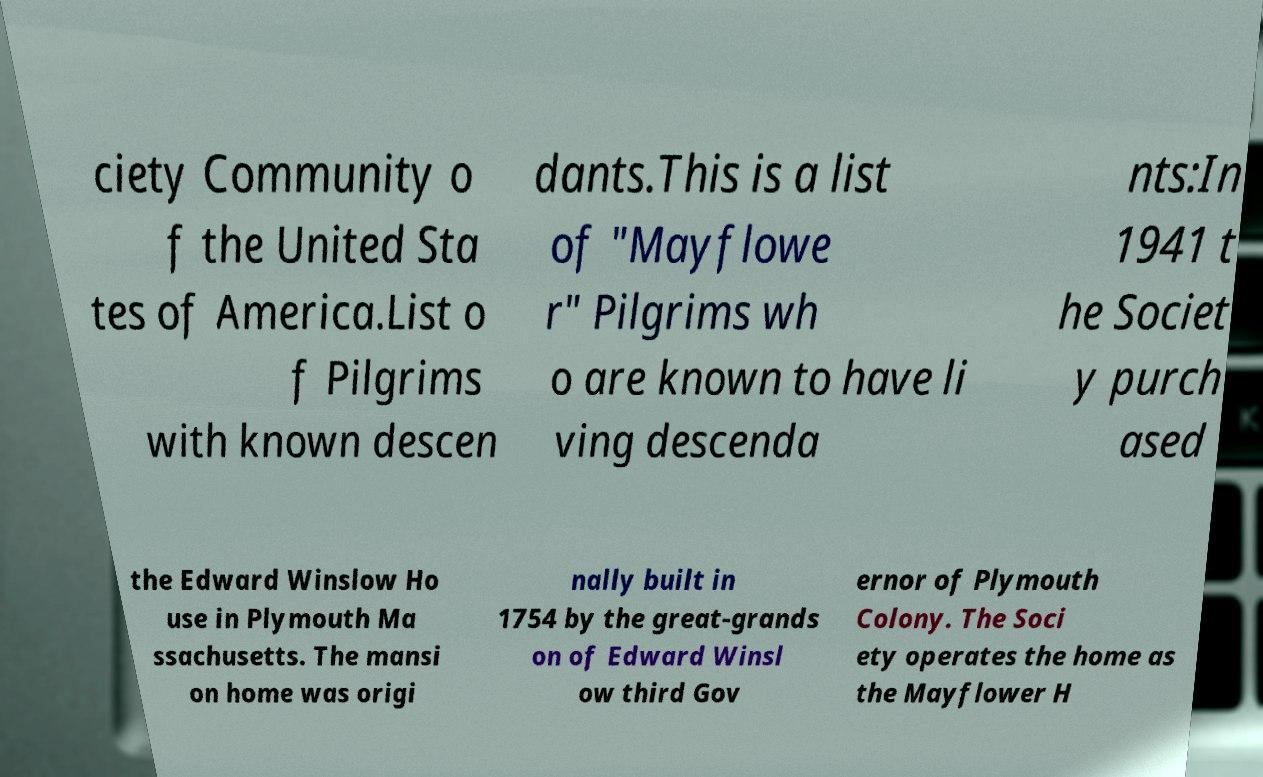I need the written content from this picture converted into text. Can you do that? ciety Community o f the United Sta tes of America.List o f Pilgrims with known descen dants.This is a list of "Mayflowe r" Pilgrims wh o are known to have li ving descenda nts:In 1941 t he Societ y purch ased the Edward Winslow Ho use in Plymouth Ma ssachusetts. The mansi on home was origi nally built in 1754 by the great-grands on of Edward Winsl ow third Gov ernor of Plymouth Colony. The Soci ety operates the home as the Mayflower H 